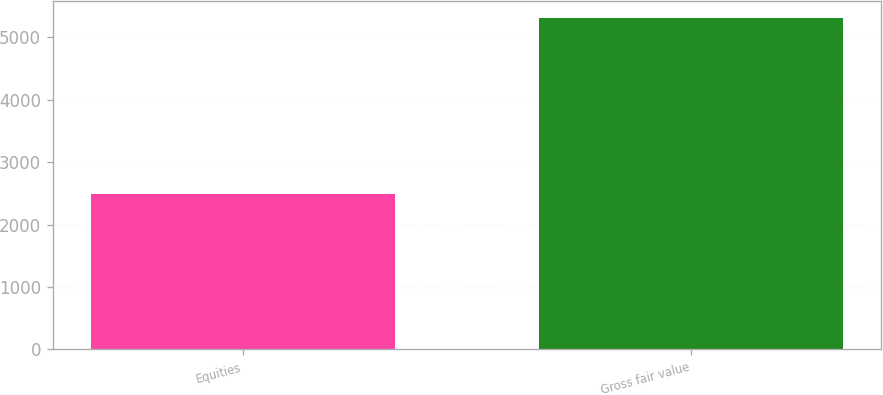Convert chart. <chart><loc_0><loc_0><loc_500><loc_500><bar_chart><fcel>Equities<fcel>Gross fair value<nl><fcel>2486<fcel>5314<nl></chart> 